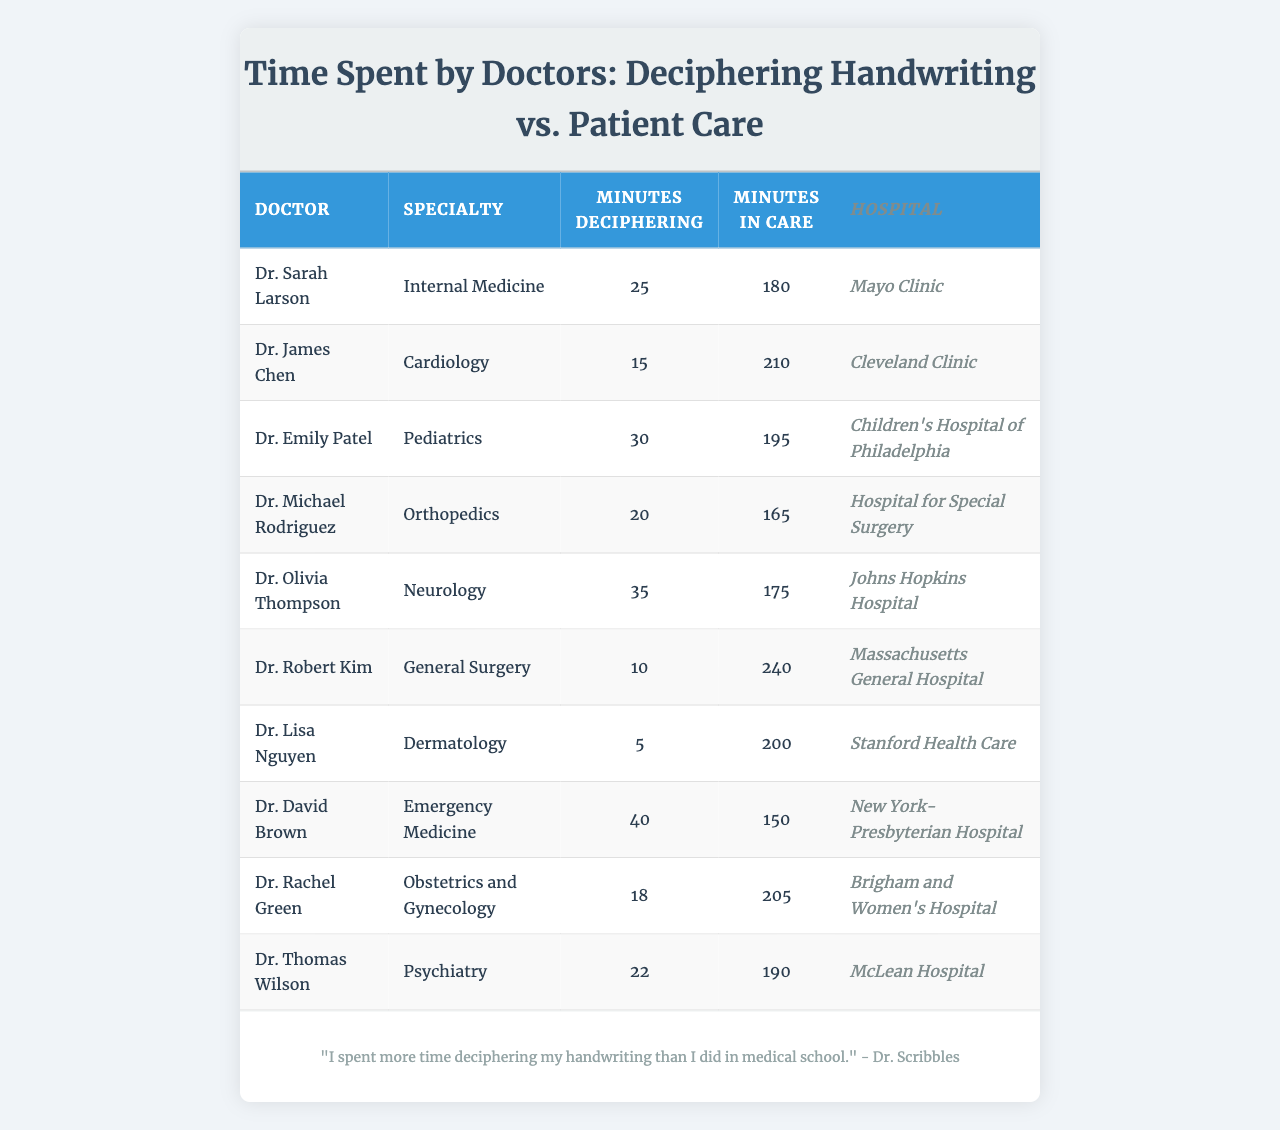What is the maximum time spent deciphering handwriting by a doctor? By reviewing the column for "Minutes Deciphering Handwriting", Dr. David Brown has the highest recorded time, which is 40 minutes.
Answer: 40 minutes Which doctor spent the least time deciphering their handwriting? Checking the "Minutes Deciphering Handwriting" column, Dr. Lisa Nguyen spent only 5 minutes deciphering her handwriting, making it the least time.
Answer: Dr. Lisa Nguyen How much total time do doctors spend deciphering handwriting versus patient care? To find the total time, I will sum the minutes for both columns. The total deciphering time is 25 + 15 + 30 + 20 + 35 + 10 + 5 + 40 + 18 + 22 = 250 minutes and the total patient care time is 180 + 210 + 195 + 165 + 175 + 240 + 200 + 150 + 205 + 190 = 1990 minutes.
Answer: 250 minutes deciphering, 1990 minutes in patient care What is the average time spent on deciphering handwriting by the doctors in the table? To calculate the average, sum the minutes (250 minutes total) and divide by the number of doctors (10). Thus, 250/10 = 25 minutes on average.
Answer: 25 minutes Did any doctor spend more time deciphering handwriting than on patient care? Comparing the "Minutes Deciphering Handwriting" and "Minutes in Patient Care" for each doctor, Dr. David Brown is the only one who spent 40 minutes deciphering, while only spending 150 minutes in patient care, showing he did.
Answer: Yes Which doctor has the highest patient care time, and how much did they spend? Looking at the "Minutes in Patient Care" column, Dr. Robert Kim has the highest figure, spending 240 minutes in care.
Answer: Dr. Robert Kim, 240 minutes Find the doctor who has the longest difference in time between deciphering handwriting and patient care. Calculate the time difference for each doctor by subtracting the deciphering time from the patient care time, the highest difference occurs with Dr. Robert Kim who spent 240 - 10 = 230 minutes more in patient care.
Answer: Dr. Robert Kim, 230 minutes difference Which specialty requires the most time deciphering handwriting on average? For this, I'll calculate the average deciphering time for each specialty based on the provided data. The averages are: Internal Medicine (25), Cardiology (15), Pediatrics (30), Orthopedics (20), Neurology (35), General Surgery (10), Dermatology (5), Emergency Medicine (40), Obstetrics (18), Psychiatry (22). Neurology has the highest average at 35 minutes.
Answer: Neurology Is there a correlation between the minutes spent deciphering handwriting and the hospital? The table does not provide direct correlation information; all hospitals featured a variety of deciphering times which do not suggest a string correlation, showing no clear pattern.
Answer: No clear correlation What percentage of time did Dr. Emily Patel spend deciphering handwriting relative to her total time spent (deciphering + patient care)? Dr. Emily Patel spent 30 minutes deciphering and 195 minutes in patient care for a total of 30 + 195 = 225 minutes. The percentage is (30/225)*100 = 13.33%.
Answer: 13.33% 